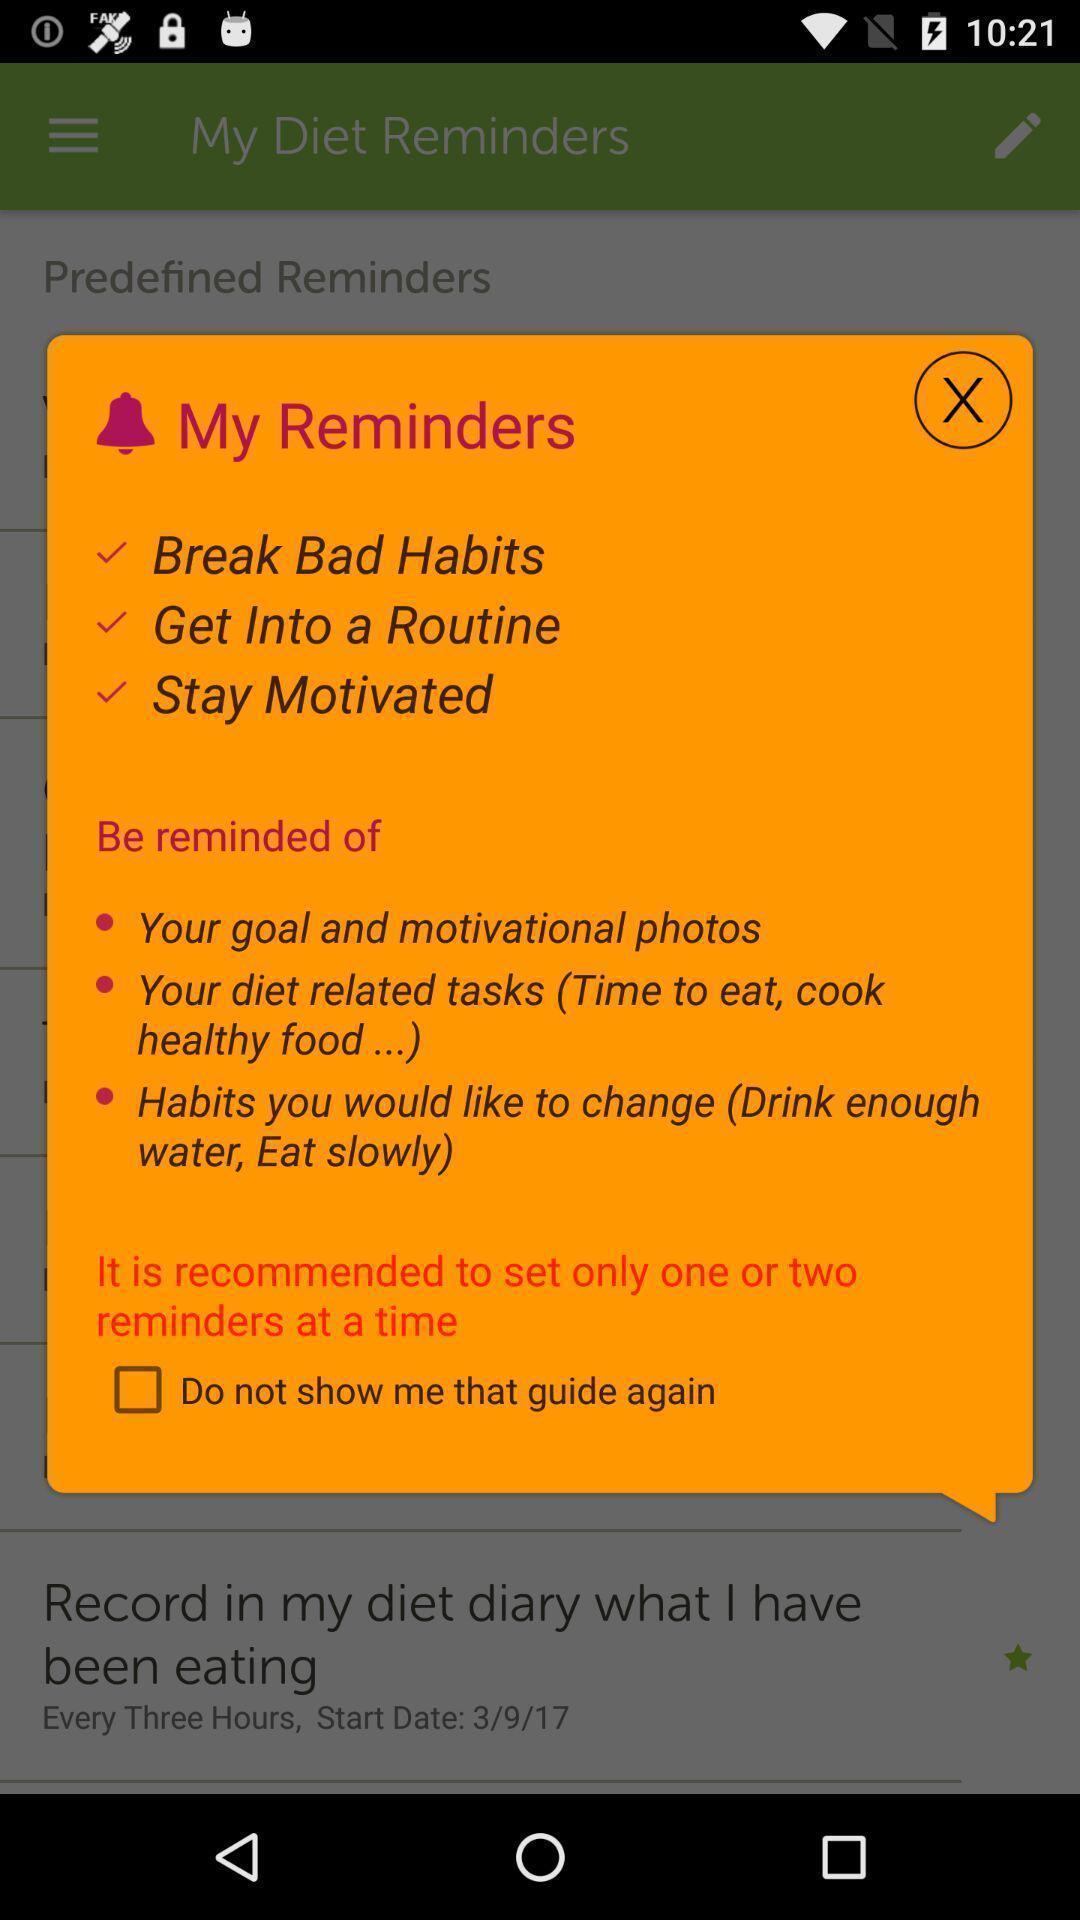What is the overall content of this screenshot? Pop-up showing my reminders page. 